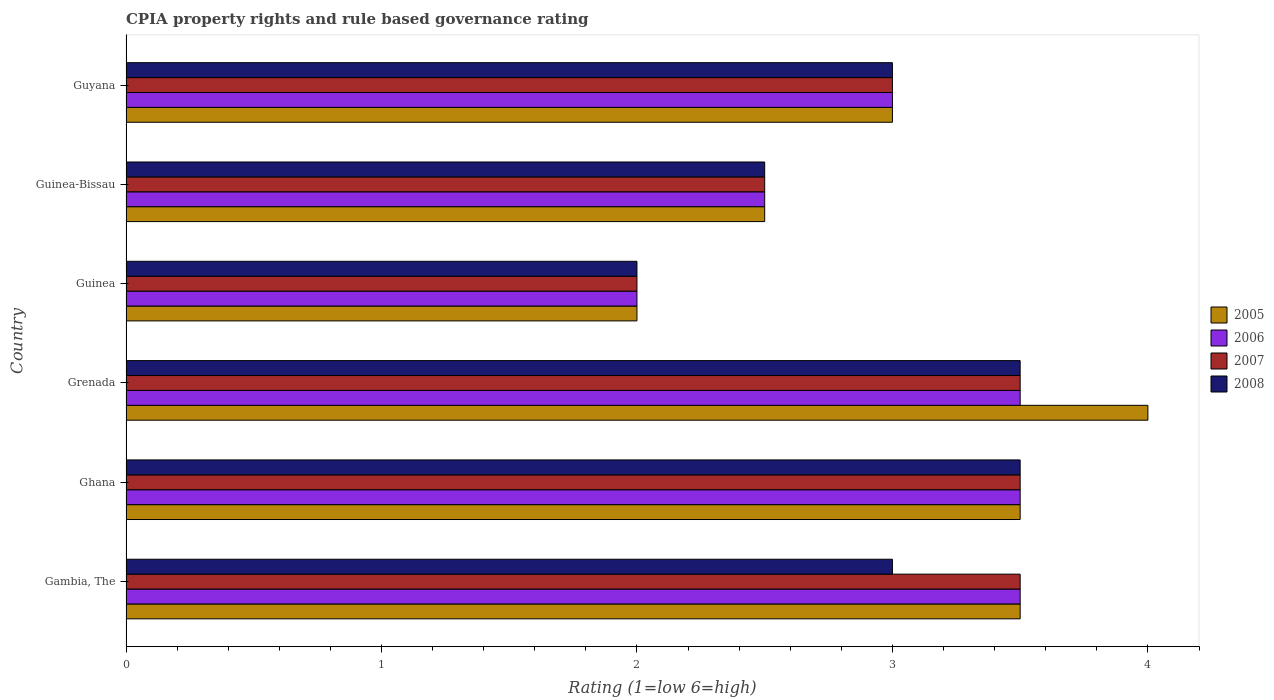How many different coloured bars are there?
Your answer should be compact. 4. Are the number of bars per tick equal to the number of legend labels?
Your answer should be compact. Yes. Are the number of bars on each tick of the Y-axis equal?
Offer a very short reply. Yes. What is the label of the 4th group of bars from the top?
Offer a very short reply. Grenada. Across all countries, what is the maximum CPIA rating in 2006?
Your answer should be compact. 3.5. In which country was the CPIA rating in 2005 maximum?
Keep it short and to the point. Grenada. In which country was the CPIA rating in 2008 minimum?
Provide a short and direct response. Guinea. What is the difference between the CPIA rating in 2005 in Ghana and that in Guinea?
Make the answer very short. 1.5. What is the average CPIA rating in 2005 per country?
Your answer should be very brief. 3.08. What is the difference between the highest and the second highest CPIA rating in 2005?
Provide a succinct answer. 0.5. What is the difference between the highest and the lowest CPIA rating in 2005?
Offer a very short reply. 2. In how many countries, is the CPIA rating in 2006 greater than the average CPIA rating in 2006 taken over all countries?
Provide a short and direct response. 3. Is it the case that in every country, the sum of the CPIA rating in 2007 and CPIA rating in 2006 is greater than the sum of CPIA rating in 2008 and CPIA rating in 2005?
Ensure brevity in your answer.  No. How many countries are there in the graph?
Your answer should be compact. 6. What is the title of the graph?
Ensure brevity in your answer.  CPIA property rights and rule based governance rating. What is the Rating (1=low 6=high) of 2006 in Gambia, The?
Make the answer very short. 3.5. What is the Rating (1=low 6=high) in 2007 in Gambia, The?
Ensure brevity in your answer.  3.5. What is the Rating (1=low 6=high) of 2006 in Ghana?
Your response must be concise. 3.5. What is the Rating (1=low 6=high) in 2007 in Ghana?
Provide a succinct answer. 3.5. What is the Rating (1=low 6=high) of 2008 in Ghana?
Keep it short and to the point. 3.5. What is the Rating (1=low 6=high) of 2005 in Grenada?
Keep it short and to the point. 4. What is the Rating (1=low 6=high) of 2006 in Grenada?
Offer a very short reply. 3.5. What is the Rating (1=low 6=high) in 2008 in Grenada?
Give a very brief answer. 3.5. What is the Rating (1=low 6=high) in 2005 in Guinea?
Your response must be concise. 2. What is the Rating (1=low 6=high) of 2005 in Guinea-Bissau?
Give a very brief answer. 2.5. What is the Rating (1=low 6=high) of 2006 in Guinea-Bissau?
Provide a succinct answer. 2.5. What is the Rating (1=low 6=high) of 2008 in Guinea-Bissau?
Offer a terse response. 2.5. What is the Rating (1=low 6=high) in 2005 in Guyana?
Give a very brief answer. 3. What is the Rating (1=low 6=high) in 2008 in Guyana?
Make the answer very short. 3. Across all countries, what is the maximum Rating (1=low 6=high) of 2007?
Ensure brevity in your answer.  3.5. Across all countries, what is the maximum Rating (1=low 6=high) in 2008?
Provide a short and direct response. 3.5. Across all countries, what is the minimum Rating (1=low 6=high) in 2006?
Your answer should be very brief. 2. What is the total Rating (1=low 6=high) of 2005 in the graph?
Your answer should be compact. 18.5. What is the total Rating (1=low 6=high) in 2008 in the graph?
Your answer should be compact. 17.5. What is the difference between the Rating (1=low 6=high) in 2005 in Gambia, The and that in Ghana?
Provide a succinct answer. 0. What is the difference between the Rating (1=low 6=high) of 2006 in Gambia, The and that in Ghana?
Offer a terse response. 0. What is the difference between the Rating (1=low 6=high) in 2007 in Gambia, The and that in Ghana?
Provide a succinct answer. 0. What is the difference between the Rating (1=low 6=high) of 2006 in Gambia, The and that in Grenada?
Your response must be concise. 0. What is the difference between the Rating (1=low 6=high) in 2007 in Gambia, The and that in Grenada?
Offer a terse response. 0. What is the difference between the Rating (1=low 6=high) in 2008 in Gambia, The and that in Grenada?
Offer a terse response. -0.5. What is the difference between the Rating (1=low 6=high) in 2006 in Gambia, The and that in Guinea?
Make the answer very short. 1.5. What is the difference between the Rating (1=low 6=high) of 2007 in Gambia, The and that in Guinea?
Offer a very short reply. 1.5. What is the difference between the Rating (1=low 6=high) of 2005 in Gambia, The and that in Guinea-Bissau?
Your answer should be compact. 1. What is the difference between the Rating (1=low 6=high) in 2006 in Gambia, The and that in Guinea-Bissau?
Your answer should be very brief. 1. What is the difference between the Rating (1=low 6=high) of 2008 in Gambia, The and that in Guinea-Bissau?
Ensure brevity in your answer.  0.5. What is the difference between the Rating (1=low 6=high) in 2006 in Gambia, The and that in Guyana?
Provide a succinct answer. 0.5. What is the difference between the Rating (1=low 6=high) in 2007 in Gambia, The and that in Guyana?
Offer a terse response. 0.5. What is the difference between the Rating (1=low 6=high) in 2005 in Ghana and that in Grenada?
Provide a short and direct response. -0.5. What is the difference between the Rating (1=low 6=high) in 2006 in Ghana and that in Grenada?
Provide a succinct answer. 0. What is the difference between the Rating (1=low 6=high) of 2007 in Ghana and that in Grenada?
Your answer should be very brief. 0. What is the difference between the Rating (1=low 6=high) of 2005 in Ghana and that in Guinea?
Make the answer very short. 1.5. What is the difference between the Rating (1=low 6=high) in 2006 in Ghana and that in Guinea?
Make the answer very short. 1.5. What is the difference between the Rating (1=low 6=high) in 2007 in Ghana and that in Guinea?
Keep it short and to the point. 1.5. What is the difference between the Rating (1=low 6=high) in 2008 in Ghana and that in Guinea?
Keep it short and to the point. 1.5. What is the difference between the Rating (1=low 6=high) of 2006 in Ghana and that in Guinea-Bissau?
Give a very brief answer. 1. What is the difference between the Rating (1=low 6=high) of 2005 in Ghana and that in Guyana?
Ensure brevity in your answer.  0.5. What is the difference between the Rating (1=low 6=high) of 2006 in Ghana and that in Guyana?
Ensure brevity in your answer.  0.5. What is the difference between the Rating (1=low 6=high) in 2007 in Ghana and that in Guyana?
Give a very brief answer. 0.5. What is the difference between the Rating (1=low 6=high) of 2008 in Ghana and that in Guyana?
Your answer should be very brief. 0.5. What is the difference between the Rating (1=low 6=high) in 2005 in Grenada and that in Guinea?
Offer a terse response. 2. What is the difference between the Rating (1=low 6=high) in 2006 in Grenada and that in Guinea?
Give a very brief answer. 1.5. What is the difference between the Rating (1=low 6=high) in 2008 in Grenada and that in Guinea?
Your response must be concise. 1.5. What is the difference between the Rating (1=low 6=high) of 2008 in Grenada and that in Guinea-Bissau?
Provide a short and direct response. 1. What is the difference between the Rating (1=low 6=high) of 2007 in Grenada and that in Guyana?
Give a very brief answer. 0.5. What is the difference between the Rating (1=low 6=high) in 2006 in Guinea and that in Guinea-Bissau?
Offer a very short reply. -0.5. What is the difference between the Rating (1=low 6=high) of 2007 in Guinea and that in Guinea-Bissau?
Make the answer very short. -0.5. What is the difference between the Rating (1=low 6=high) of 2008 in Guinea and that in Guinea-Bissau?
Make the answer very short. -0.5. What is the difference between the Rating (1=low 6=high) of 2005 in Guinea and that in Guyana?
Make the answer very short. -1. What is the difference between the Rating (1=low 6=high) of 2008 in Guinea and that in Guyana?
Give a very brief answer. -1. What is the difference between the Rating (1=low 6=high) in 2005 in Guinea-Bissau and that in Guyana?
Your answer should be compact. -0.5. What is the difference between the Rating (1=low 6=high) in 2006 in Guinea-Bissau and that in Guyana?
Provide a short and direct response. -0.5. What is the difference between the Rating (1=low 6=high) in 2008 in Guinea-Bissau and that in Guyana?
Make the answer very short. -0.5. What is the difference between the Rating (1=low 6=high) of 2005 in Gambia, The and the Rating (1=low 6=high) of 2006 in Ghana?
Give a very brief answer. 0. What is the difference between the Rating (1=low 6=high) of 2005 in Gambia, The and the Rating (1=low 6=high) of 2007 in Ghana?
Keep it short and to the point. 0. What is the difference between the Rating (1=low 6=high) in 2006 in Gambia, The and the Rating (1=low 6=high) in 2007 in Ghana?
Provide a short and direct response. 0. What is the difference between the Rating (1=low 6=high) of 2006 in Gambia, The and the Rating (1=low 6=high) of 2008 in Ghana?
Provide a short and direct response. 0. What is the difference between the Rating (1=low 6=high) in 2005 in Gambia, The and the Rating (1=low 6=high) in 2006 in Grenada?
Provide a succinct answer. 0. What is the difference between the Rating (1=low 6=high) of 2005 in Gambia, The and the Rating (1=low 6=high) of 2007 in Grenada?
Make the answer very short. 0. What is the difference between the Rating (1=low 6=high) of 2005 in Gambia, The and the Rating (1=low 6=high) of 2008 in Grenada?
Provide a succinct answer. 0. What is the difference between the Rating (1=low 6=high) in 2006 in Gambia, The and the Rating (1=low 6=high) in 2008 in Grenada?
Offer a very short reply. 0. What is the difference between the Rating (1=low 6=high) of 2005 in Gambia, The and the Rating (1=low 6=high) of 2007 in Guinea?
Offer a very short reply. 1.5. What is the difference between the Rating (1=low 6=high) in 2006 in Gambia, The and the Rating (1=low 6=high) in 2008 in Guinea?
Your answer should be compact. 1.5. What is the difference between the Rating (1=low 6=high) in 2007 in Gambia, The and the Rating (1=low 6=high) in 2008 in Guinea?
Offer a terse response. 1.5. What is the difference between the Rating (1=low 6=high) of 2005 in Gambia, The and the Rating (1=low 6=high) of 2007 in Guinea-Bissau?
Your response must be concise. 1. What is the difference between the Rating (1=low 6=high) of 2005 in Gambia, The and the Rating (1=low 6=high) of 2006 in Guyana?
Give a very brief answer. 0.5. What is the difference between the Rating (1=low 6=high) of 2005 in Gambia, The and the Rating (1=low 6=high) of 2008 in Guyana?
Make the answer very short. 0.5. What is the difference between the Rating (1=low 6=high) of 2006 in Gambia, The and the Rating (1=low 6=high) of 2008 in Guyana?
Make the answer very short. 0.5. What is the difference between the Rating (1=low 6=high) in 2007 in Gambia, The and the Rating (1=low 6=high) in 2008 in Guyana?
Offer a terse response. 0.5. What is the difference between the Rating (1=low 6=high) in 2005 in Ghana and the Rating (1=low 6=high) in 2006 in Grenada?
Give a very brief answer. 0. What is the difference between the Rating (1=low 6=high) of 2005 in Ghana and the Rating (1=low 6=high) of 2008 in Grenada?
Your response must be concise. 0. What is the difference between the Rating (1=low 6=high) in 2006 in Ghana and the Rating (1=low 6=high) in 2007 in Grenada?
Keep it short and to the point. 0. What is the difference between the Rating (1=low 6=high) of 2006 in Ghana and the Rating (1=low 6=high) of 2008 in Grenada?
Offer a very short reply. 0. What is the difference between the Rating (1=low 6=high) in 2007 in Ghana and the Rating (1=low 6=high) in 2008 in Grenada?
Give a very brief answer. 0. What is the difference between the Rating (1=low 6=high) of 2005 in Ghana and the Rating (1=low 6=high) of 2008 in Guinea?
Provide a succinct answer. 1.5. What is the difference between the Rating (1=low 6=high) in 2007 in Ghana and the Rating (1=low 6=high) in 2008 in Guinea?
Ensure brevity in your answer.  1.5. What is the difference between the Rating (1=low 6=high) in 2005 in Ghana and the Rating (1=low 6=high) in 2006 in Guinea-Bissau?
Offer a terse response. 1. What is the difference between the Rating (1=low 6=high) of 2005 in Ghana and the Rating (1=low 6=high) of 2007 in Guinea-Bissau?
Give a very brief answer. 1. What is the difference between the Rating (1=low 6=high) of 2006 in Ghana and the Rating (1=low 6=high) of 2007 in Guinea-Bissau?
Offer a very short reply. 1. What is the difference between the Rating (1=low 6=high) of 2006 in Ghana and the Rating (1=low 6=high) of 2008 in Guinea-Bissau?
Your answer should be very brief. 1. What is the difference between the Rating (1=low 6=high) in 2007 in Ghana and the Rating (1=low 6=high) in 2008 in Guinea-Bissau?
Ensure brevity in your answer.  1. What is the difference between the Rating (1=low 6=high) in 2005 in Ghana and the Rating (1=low 6=high) in 2006 in Guyana?
Make the answer very short. 0.5. What is the difference between the Rating (1=low 6=high) in 2005 in Ghana and the Rating (1=low 6=high) in 2007 in Guyana?
Ensure brevity in your answer.  0.5. What is the difference between the Rating (1=low 6=high) of 2006 in Ghana and the Rating (1=low 6=high) of 2008 in Guyana?
Offer a very short reply. 0.5. What is the difference between the Rating (1=low 6=high) of 2005 in Grenada and the Rating (1=low 6=high) of 2006 in Guinea?
Provide a succinct answer. 2. What is the difference between the Rating (1=low 6=high) of 2005 in Grenada and the Rating (1=low 6=high) of 2007 in Guinea?
Provide a succinct answer. 2. What is the difference between the Rating (1=low 6=high) in 2006 in Grenada and the Rating (1=low 6=high) in 2007 in Guinea?
Make the answer very short. 1.5. What is the difference between the Rating (1=low 6=high) in 2006 in Grenada and the Rating (1=low 6=high) in 2008 in Guinea?
Your answer should be compact. 1.5. What is the difference between the Rating (1=low 6=high) of 2006 in Grenada and the Rating (1=low 6=high) of 2007 in Guinea-Bissau?
Your answer should be very brief. 1. What is the difference between the Rating (1=low 6=high) in 2006 in Grenada and the Rating (1=low 6=high) in 2008 in Guinea-Bissau?
Offer a terse response. 1. What is the difference between the Rating (1=low 6=high) in 2007 in Grenada and the Rating (1=low 6=high) in 2008 in Guyana?
Offer a terse response. 0.5. What is the difference between the Rating (1=low 6=high) of 2006 in Guinea and the Rating (1=low 6=high) of 2007 in Guinea-Bissau?
Your answer should be compact. -0.5. What is the difference between the Rating (1=low 6=high) of 2007 in Guinea and the Rating (1=low 6=high) of 2008 in Guinea-Bissau?
Offer a very short reply. -0.5. What is the difference between the Rating (1=low 6=high) in 2005 in Guinea and the Rating (1=low 6=high) in 2006 in Guyana?
Your answer should be compact. -1. What is the difference between the Rating (1=low 6=high) in 2005 in Guinea and the Rating (1=low 6=high) in 2008 in Guyana?
Your answer should be compact. -1. What is the difference between the Rating (1=low 6=high) of 2007 in Guinea and the Rating (1=low 6=high) of 2008 in Guyana?
Ensure brevity in your answer.  -1. What is the difference between the Rating (1=low 6=high) of 2005 in Guinea-Bissau and the Rating (1=low 6=high) of 2007 in Guyana?
Your answer should be very brief. -0.5. What is the difference between the Rating (1=low 6=high) in 2005 in Guinea-Bissau and the Rating (1=low 6=high) in 2008 in Guyana?
Your response must be concise. -0.5. What is the difference between the Rating (1=low 6=high) of 2006 in Guinea-Bissau and the Rating (1=low 6=high) of 2008 in Guyana?
Ensure brevity in your answer.  -0.5. What is the average Rating (1=low 6=high) in 2005 per country?
Provide a succinct answer. 3.08. What is the average Rating (1=low 6=high) in 2007 per country?
Your answer should be compact. 3. What is the average Rating (1=low 6=high) in 2008 per country?
Your answer should be very brief. 2.92. What is the difference between the Rating (1=low 6=high) of 2006 and Rating (1=low 6=high) of 2007 in Gambia, The?
Give a very brief answer. 0. What is the difference between the Rating (1=low 6=high) of 2006 and Rating (1=low 6=high) of 2008 in Gambia, The?
Make the answer very short. 0.5. What is the difference between the Rating (1=low 6=high) of 2005 and Rating (1=low 6=high) of 2006 in Ghana?
Keep it short and to the point. 0. What is the difference between the Rating (1=low 6=high) of 2006 and Rating (1=low 6=high) of 2008 in Ghana?
Give a very brief answer. 0. What is the difference between the Rating (1=low 6=high) in 2005 and Rating (1=low 6=high) in 2007 in Grenada?
Your response must be concise. 0.5. What is the difference between the Rating (1=low 6=high) in 2005 and Rating (1=low 6=high) in 2008 in Grenada?
Offer a terse response. 0.5. What is the difference between the Rating (1=low 6=high) of 2006 and Rating (1=low 6=high) of 2008 in Grenada?
Offer a terse response. 0. What is the difference between the Rating (1=low 6=high) of 2005 and Rating (1=low 6=high) of 2007 in Guinea?
Offer a terse response. 0. What is the difference between the Rating (1=low 6=high) in 2005 and Rating (1=low 6=high) in 2008 in Guinea?
Give a very brief answer. 0. What is the difference between the Rating (1=low 6=high) in 2006 and Rating (1=low 6=high) in 2007 in Guinea?
Offer a very short reply. 0. What is the difference between the Rating (1=low 6=high) in 2007 and Rating (1=low 6=high) in 2008 in Guinea?
Keep it short and to the point. 0. What is the difference between the Rating (1=low 6=high) in 2007 and Rating (1=low 6=high) in 2008 in Guinea-Bissau?
Ensure brevity in your answer.  0. What is the difference between the Rating (1=low 6=high) of 2006 and Rating (1=low 6=high) of 2007 in Guyana?
Your answer should be very brief. 0. What is the difference between the Rating (1=low 6=high) of 2006 and Rating (1=low 6=high) of 2008 in Guyana?
Your answer should be compact. 0. What is the difference between the Rating (1=low 6=high) of 2007 and Rating (1=low 6=high) of 2008 in Guyana?
Your answer should be compact. 0. What is the ratio of the Rating (1=low 6=high) of 2005 in Gambia, The to that in Ghana?
Offer a terse response. 1. What is the ratio of the Rating (1=low 6=high) of 2006 in Gambia, The to that in Ghana?
Provide a short and direct response. 1. What is the ratio of the Rating (1=low 6=high) of 2008 in Gambia, The to that in Ghana?
Keep it short and to the point. 0.86. What is the ratio of the Rating (1=low 6=high) in 2006 in Gambia, The to that in Grenada?
Provide a short and direct response. 1. What is the ratio of the Rating (1=low 6=high) of 2007 in Gambia, The to that in Grenada?
Ensure brevity in your answer.  1. What is the ratio of the Rating (1=low 6=high) of 2008 in Gambia, The to that in Grenada?
Your answer should be very brief. 0.86. What is the ratio of the Rating (1=low 6=high) of 2005 in Gambia, The to that in Guinea?
Provide a succinct answer. 1.75. What is the ratio of the Rating (1=low 6=high) in 2006 in Gambia, The to that in Guinea?
Provide a short and direct response. 1.75. What is the ratio of the Rating (1=low 6=high) of 2008 in Gambia, The to that in Guinea?
Ensure brevity in your answer.  1.5. What is the ratio of the Rating (1=low 6=high) in 2008 in Gambia, The to that in Guinea-Bissau?
Offer a terse response. 1.2. What is the ratio of the Rating (1=low 6=high) of 2007 in Gambia, The to that in Guyana?
Keep it short and to the point. 1.17. What is the ratio of the Rating (1=low 6=high) of 2008 in Gambia, The to that in Guyana?
Offer a terse response. 1. What is the ratio of the Rating (1=low 6=high) of 2006 in Ghana to that in Grenada?
Offer a terse response. 1. What is the ratio of the Rating (1=low 6=high) in 2008 in Ghana to that in Guinea?
Offer a very short reply. 1.75. What is the ratio of the Rating (1=low 6=high) in 2007 in Ghana to that in Guinea-Bissau?
Make the answer very short. 1.4. What is the ratio of the Rating (1=low 6=high) in 2005 in Ghana to that in Guyana?
Ensure brevity in your answer.  1.17. What is the ratio of the Rating (1=low 6=high) of 2006 in Ghana to that in Guyana?
Make the answer very short. 1.17. What is the ratio of the Rating (1=low 6=high) of 2008 in Ghana to that in Guyana?
Provide a short and direct response. 1.17. What is the ratio of the Rating (1=low 6=high) of 2007 in Grenada to that in Guinea?
Ensure brevity in your answer.  1.75. What is the ratio of the Rating (1=low 6=high) in 2007 in Grenada to that in Guinea-Bissau?
Your answer should be compact. 1.4. What is the ratio of the Rating (1=low 6=high) in 2006 in Grenada to that in Guyana?
Your answer should be very brief. 1.17. What is the ratio of the Rating (1=low 6=high) of 2008 in Grenada to that in Guyana?
Your response must be concise. 1.17. What is the ratio of the Rating (1=low 6=high) in 2005 in Guinea to that in Guinea-Bissau?
Make the answer very short. 0.8. What is the ratio of the Rating (1=low 6=high) in 2006 in Guinea to that in Guinea-Bissau?
Offer a terse response. 0.8. What is the ratio of the Rating (1=low 6=high) of 2006 in Guinea to that in Guyana?
Your response must be concise. 0.67. What is the ratio of the Rating (1=low 6=high) of 2007 in Guinea to that in Guyana?
Offer a very short reply. 0.67. What is the ratio of the Rating (1=low 6=high) in 2008 in Guinea to that in Guyana?
Make the answer very short. 0.67. What is the ratio of the Rating (1=low 6=high) in 2005 in Guinea-Bissau to that in Guyana?
Provide a succinct answer. 0.83. What is the ratio of the Rating (1=low 6=high) of 2006 in Guinea-Bissau to that in Guyana?
Ensure brevity in your answer.  0.83. What is the ratio of the Rating (1=low 6=high) in 2008 in Guinea-Bissau to that in Guyana?
Provide a short and direct response. 0.83. What is the difference between the highest and the second highest Rating (1=low 6=high) in 2006?
Provide a succinct answer. 0. What is the difference between the highest and the lowest Rating (1=low 6=high) of 2005?
Provide a short and direct response. 2. What is the difference between the highest and the lowest Rating (1=low 6=high) in 2006?
Provide a succinct answer. 1.5. What is the difference between the highest and the lowest Rating (1=low 6=high) in 2007?
Your response must be concise. 1.5. What is the difference between the highest and the lowest Rating (1=low 6=high) of 2008?
Provide a short and direct response. 1.5. 